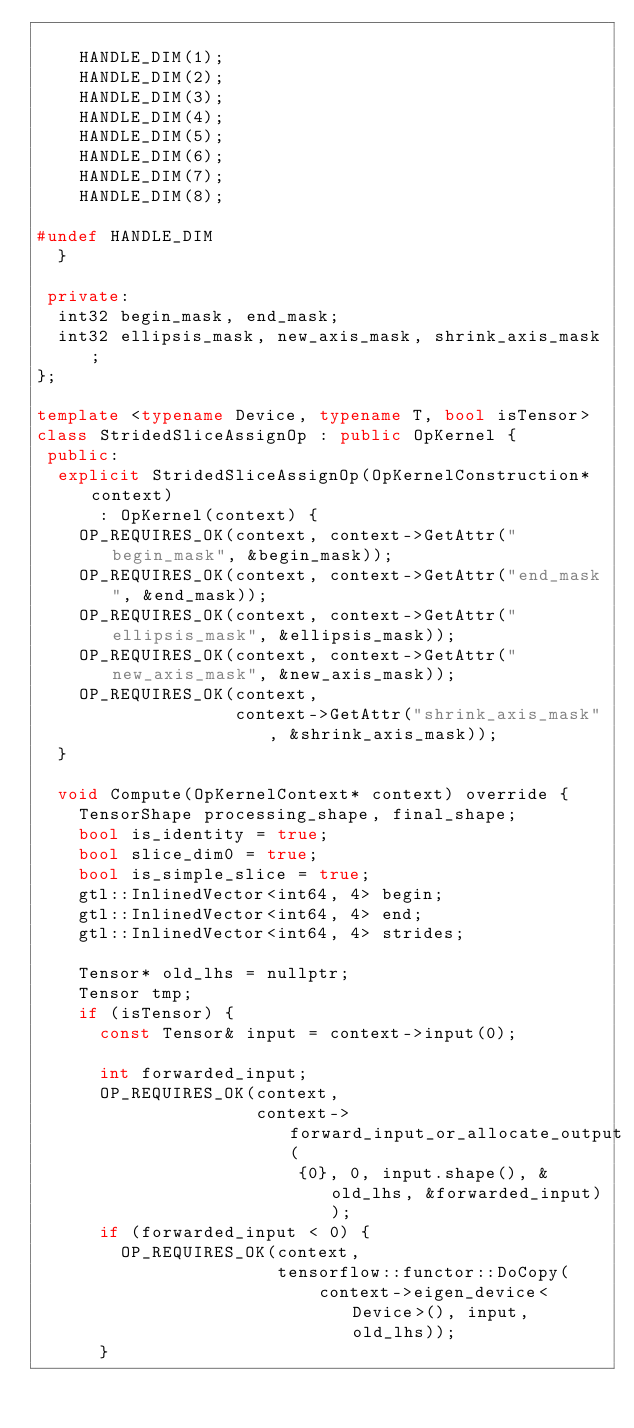<code> <loc_0><loc_0><loc_500><loc_500><_C++_>
    HANDLE_DIM(1);
    HANDLE_DIM(2);
    HANDLE_DIM(3);
    HANDLE_DIM(4);
    HANDLE_DIM(5);
    HANDLE_DIM(6);
    HANDLE_DIM(7);
    HANDLE_DIM(8);

#undef HANDLE_DIM
  }

 private:
  int32 begin_mask, end_mask;
  int32 ellipsis_mask, new_axis_mask, shrink_axis_mask;
};

template <typename Device, typename T, bool isTensor>
class StridedSliceAssignOp : public OpKernel {
 public:
  explicit StridedSliceAssignOp(OpKernelConstruction* context)
      : OpKernel(context) {
    OP_REQUIRES_OK(context, context->GetAttr("begin_mask", &begin_mask));
    OP_REQUIRES_OK(context, context->GetAttr("end_mask", &end_mask));
    OP_REQUIRES_OK(context, context->GetAttr("ellipsis_mask", &ellipsis_mask));
    OP_REQUIRES_OK(context, context->GetAttr("new_axis_mask", &new_axis_mask));
    OP_REQUIRES_OK(context,
                   context->GetAttr("shrink_axis_mask", &shrink_axis_mask));
  }

  void Compute(OpKernelContext* context) override {
    TensorShape processing_shape, final_shape;
    bool is_identity = true;
    bool slice_dim0 = true;
    bool is_simple_slice = true;
    gtl::InlinedVector<int64, 4> begin;
    gtl::InlinedVector<int64, 4> end;
    gtl::InlinedVector<int64, 4> strides;

    Tensor* old_lhs = nullptr;
    Tensor tmp;
    if (isTensor) {
      const Tensor& input = context->input(0);

      int forwarded_input;
      OP_REQUIRES_OK(context,
                     context->forward_input_or_allocate_output(
                         {0}, 0, input.shape(), &old_lhs, &forwarded_input));
      if (forwarded_input < 0) {
        OP_REQUIRES_OK(context,
                       tensorflow::functor::DoCopy(
                           context->eigen_device<Device>(), input, old_lhs));
      }</code> 